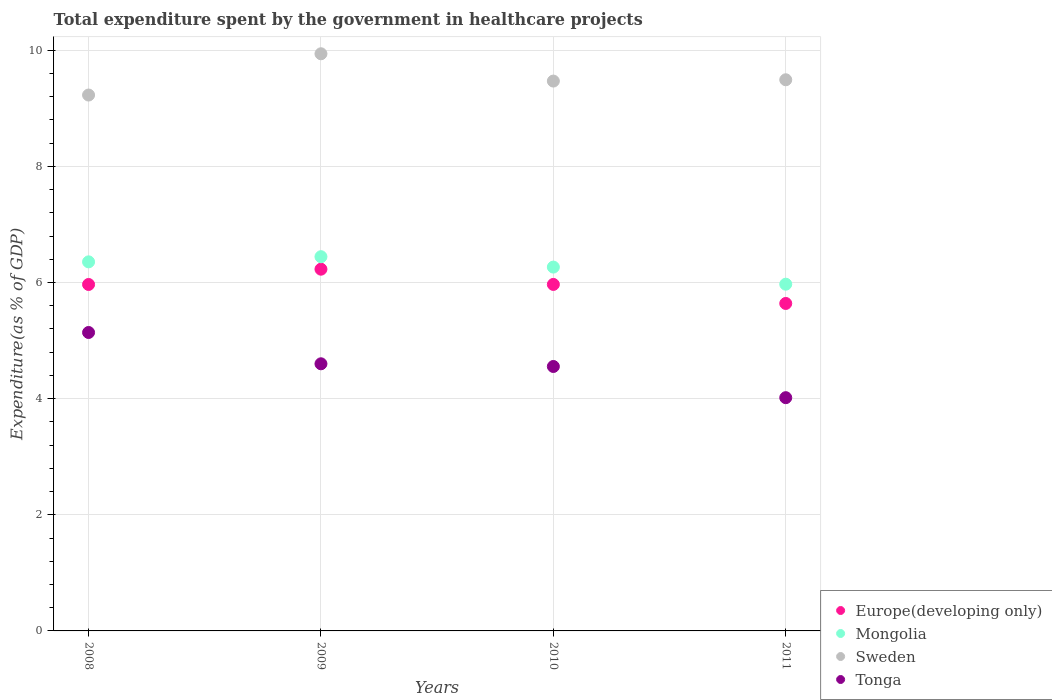How many different coloured dotlines are there?
Ensure brevity in your answer.  4. What is the total expenditure spent by the government in healthcare projects in Sweden in 2011?
Keep it short and to the point. 9.49. Across all years, what is the maximum total expenditure spent by the government in healthcare projects in Sweden?
Offer a very short reply. 9.94. Across all years, what is the minimum total expenditure spent by the government in healthcare projects in Europe(developing only)?
Give a very brief answer. 5.64. In which year was the total expenditure spent by the government in healthcare projects in Mongolia minimum?
Your answer should be compact. 2011. What is the total total expenditure spent by the government in healthcare projects in Mongolia in the graph?
Offer a terse response. 25.04. What is the difference between the total expenditure spent by the government in healthcare projects in Sweden in 2009 and that in 2010?
Give a very brief answer. 0.47. What is the difference between the total expenditure spent by the government in healthcare projects in Sweden in 2011 and the total expenditure spent by the government in healthcare projects in Tonga in 2009?
Your response must be concise. 4.89. What is the average total expenditure spent by the government in healthcare projects in Mongolia per year?
Ensure brevity in your answer.  6.26. In the year 2011, what is the difference between the total expenditure spent by the government in healthcare projects in Mongolia and total expenditure spent by the government in healthcare projects in Tonga?
Provide a succinct answer. 1.95. What is the ratio of the total expenditure spent by the government in healthcare projects in Europe(developing only) in 2008 to that in 2009?
Make the answer very short. 0.96. Is the total expenditure spent by the government in healthcare projects in Tonga in 2009 less than that in 2011?
Your answer should be compact. No. Is the difference between the total expenditure spent by the government in healthcare projects in Mongolia in 2009 and 2010 greater than the difference between the total expenditure spent by the government in healthcare projects in Tonga in 2009 and 2010?
Offer a very short reply. Yes. What is the difference between the highest and the second highest total expenditure spent by the government in healthcare projects in Europe(developing only)?
Give a very brief answer. 0.26. What is the difference between the highest and the lowest total expenditure spent by the government in healthcare projects in Europe(developing only)?
Your answer should be compact. 0.59. Is the total expenditure spent by the government in healthcare projects in Mongolia strictly greater than the total expenditure spent by the government in healthcare projects in Tonga over the years?
Offer a terse response. Yes. How many dotlines are there?
Your response must be concise. 4. Does the graph contain any zero values?
Offer a terse response. No. How many legend labels are there?
Offer a very short reply. 4. How are the legend labels stacked?
Provide a short and direct response. Vertical. What is the title of the graph?
Offer a terse response. Total expenditure spent by the government in healthcare projects. Does "Austria" appear as one of the legend labels in the graph?
Your answer should be very brief. No. What is the label or title of the X-axis?
Your answer should be very brief. Years. What is the label or title of the Y-axis?
Your answer should be compact. Expenditure(as % of GDP). What is the Expenditure(as % of GDP) of Europe(developing only) in 2008?
Offer a very short reply. 5.97. What is the Expenditure(as % of GDP) in Mongolia in 2008?
Give a very brief answer. 6.36. What is the Expenditure(as % of GDP) of Sweden in 2008?
Make the answer very short. 9.23. What is the Expenditure(as % of GDP) in Tonga in 2008?
Offer a very short reply. 5.14. What is the Expenditure(as % of GDP) of Europe(developing only) in 2009?
Make the answer very short. 6.23. What is the Expenditure(as % of GDP) in Mongolia in 2009?
Give a very brief answer. 6.44. What is the Expenditure(as % of GDP) in Sweden in 2009?
Offer a very short reply. 9.94. What is the Expenditure(as % of GDP) of Tonga in 2009?
Your answer should be very brief. 4.6. What is the Expenditure(as % of GDP) of Europe(developing only) in 2010?
Provide a short and direct response. 5.97. What is the Expenditure(as % of GDP) of Mongolia in 2010?
Ensure brevity in your answer.  6.27. What is the Expenditure(as % of GDP) of Sweden in 2010?
Your answer should be very brief. 9.47. What is the Expenditure(as % of GDP) of Tonga in 2010?
Keep it short and to the point. 4.55. What is the Expenditure(as % of GDP) in Europe(developing only) in 2011?
Keep it short and to the point. 5.64. What is the Expenditure(as % of GDP) of Mongolia in 2011?
Ensure brevity in your answer.  5.97. What is the Expenditure(as % of GDP) in Sweden in 2011?
Provide a short and direct response. 9.49. What is the Expenditure(as % of GDP) in Tonga in 2011?
Ensure brevity in your answer.  4.02. Across all years, what is the maximum Expenditure(as % of GDP) of Europe(developing only)?
Your answer should be very brief. 6.23. Across all years, what is the maximum Expenditure(as % of GDP) in Mongolia?
Provide a short and direct response. 6.44. Across all years, what is the maximum Expenditure(as % of GDP) of Sweden?
Your answer should be compact. 9.94. Across all years, what is the maximum Expenditure(as % of GDP) of Tonga?
Make the answer very short. 5.14. Across all years, what is the minimum Expenditure(as % of GDP) in Europe(developing only)?
Give a very brief answer. 5.64. Across all years, what is the minimum Expenditure(as % of GDP) of Mongolia?
Offer a terse response. 5.97. Across all years, what is the minimum Expenditure(as % of GDP) of Sweden?
Keep it short and to the point. 9.23. Across all years, what is the minimum Expenditure(as % of GDP) of Tonga?
Provide a short and direct response. 4.02. What is the total Expenditure(as % of GDP) of Europe(developing only) in the graph?
Your response must be concise. 23.8. What is the total Expenditure(as % of GDP) in Mongolia in the graph?
Offer a very short reply. 25.04. What is the total Expenditure(as % of GDP) in Sweden in the graph?
Your answer should be very brief. 38.13. What is the total Expenditure(as % of GDP) in Tonga in the graph?
Provide a short and direct response. 18.31. What is the difference between the Expenditure(as % of GDP) in Europe(developing only) in 2008 and that in 2009?
Offer a very short reply. -0.26. What is the difference between the Expenditure(as % of GDP) in Mongolia in 2008 and that in 2009?
Keep it short and to the point. -0.09. What is the difference between the Expenditure(as % of GDP) of Sweden in 2008 and that in 2009?
Your response must be concise. -0.71. What is the difference between the Expenditure(as % of GDP) of Tonga in 2008 and that in 2009?
Keep it short and to the point. 0.54. What is the difference between the Expenditure(as % of GDP) of Europe(developing only) in 2008 and that in 2010?
Your answer should be compact. -0. What is the difference between the Expenditure(as % of GDP) in Mongolia in 2008 and that in 2010?
Offer a very short reply. 0.09. What is the difference between the Expenditure(as % of GDP) in Sweden in 2008 and that in 2010?
Offer a very short reply. -0.24. What is the difference between the Expenditure(as % of GDP) of Tonga in 2008 and that in 2010?
Your response must be concise. 0.59. What is the difference between the Expenditure(as % of GDP) of Europe(developing only) in 2008 and that in 2011?
Make the answer very short. 0.33. What is the difference between the Expenditure(as % of GDP) in Mongolia in 2008 and that in 2011?
Offer a terse response. 0.38. What is the difference between the Expenditure(as % of GDP) of Sweden in 2008 and that in 2011?
Ensure brevity in your answer.  -0.26. What is the difference between the Expenditure(as % of GDP) of Tonga in 2008 and that in 2011?
Make the answer very short. 1.12. What is the difference between the Expenditure(as % of GDP) in Europe(developing only) in 2009 and that in 2010?
Ensure brevity in your answer.  0.26. What is the difference between the Expenditure(as % of GDP) of Mongolia in 2009 and that in 2010?
Your response must be concise. 0.18. What is the difference between the Expenditure(as % of GDP) in Sweden in 2009 and that in 2010?
Provide a succinct answer. 0.47. What is the difference between the Expenditure(as % of GDP) in Tonga in 2009 and that in 2010?
Your response must be concise. 0.05. What is the difference between the Expenditure(as % of GDP) in Europe(developing only) in 2009 and that in 2011?
Offer a very short reply. 0.59. What is the difference between the Expenditure(as % of GDP) in Mongolia in 2009 and that in 2011?
Make the answer very short. 0.47. What is the difference between the Expenditure(as % of GDP) in Sweden in 2009 and that in 2011?
Ensure brevity in your answer.  0.45. What is the difference between the Expenditure(as % of GDP) in Tonga in 2009 and that in 2011?
Give a very brief answer. 0.58. What is the difference between the Expenditure(as % of GDP) of Europe(developing only) in 2010 and that in 2011?
Make the answer very short. 0.33. What is the difference between the Expenditure(as % of GDP) in Mongolia in 2010 and that in 2011?
Keep it short and to the point. 0.29. What is the difference between the Expenditure(as % of GDP) in Sweden in 2010 and that in 2011?
Your answer should be compact. -0.02. What is the difference between the Expenditure(as % of GDP) of Tonga in 2010 and that in 2011?
Ensure brevity in your answer.  0.54. What is the difference between the Expenditure(as % of GDP) in Europe(developing only) in 2008 and the Expenditure(as % of GDP) in Mongolia in 2009?
Your response must be concise. -0.48. What is the difference between the Expenditure(as % of GDP) of Europe(developing only) in 2008 and the Expenditure(as % of GDP) of Sweden in 2009?
Provide a short and direct response. -3.97. What is the difference between the Expenditure(as % of GDP) in Europe(developing only) in 2008 and the Expenditure(as % of GDP) in Tonga in 2009?
Offer a terse response. 1.37. What is the difference between the Expenditure(as % of GDP) of Mongolia in 2008 and the Expenditure(as % of GDP) of Sweden in 2009?
Offer a terse response. -3.58. What is the difference between the Expenditure(as % of GDP) of Mongolia in 2008 and the Expenditure(as % of GDP) of Tonga in 2009?
Your response must be concise. 1.76. What is the difference between the Expenditure(as % of GDP) of Sweden in 2008 and the Expenditure(as % of GDP) of Tonga in 2009?
Your answer should be compact. 4.63. What is the difference between the Expenditure(as % of GDP) of Europe(developing only) in 2008 and the Expenditure(as % of GDP) of Mongolia in 2010?
Make the answer very short. -0.3. What is the difference between the Expenditure(as % of GDP) of Europe(developing only) in 2008 and the Expenditure(as % of GDP) of Sweden in 2010?
Provide a succinct answer. -3.5. What is the difference between the Expenditure(as % of GDP) of Europe(developing only) in 2008 and the Expenditure(as % of GDP) of Tonga in 2010?
Offer a very short reply. 1.41. What is the difference between the Expenditure(as % of GDP) of Mongolia in 2008 and the Expenditure(as % of GDP) of Sweden in 2010?
Offer a very short reply. -3.11. What is the difference between the Expenditure(as % of GDP) of Mongolia in 2008 and the Expenditure(as % of GDP) of Tonga in 2010?
Make the answer very short. 1.8. What is the difference between the Expenditure(as % of GDP) in Sweden in 2008 and the Expenditure(as % of GDP) in Tonga in 2010?
Offer a terse response. 4.67. What is the difference between the Expenditure(as % of GDP) of Europe(developing only) in 2008 and the Expenditure(as % of GDP) of Mongolia in 2011?
Your answer should be very brief. -0. What is the difference between the Expenditure(as % of GDP) in Europe(developing only) in 2008 and the Expenditure(as % of GDP) in Sweden in 2011?
Make the answer very short. -3.53. What is the difference between the Expenditure(as % of GDP) in Europe(developing only) in 2008 and the Expenditure(as % of GDP) in Tonga in 2011?
Provide a short and direct response. 1.95. What is the difference between the Expenditure(as % of GDP) in Mongolia in 2008 and the Expenditure(as % of GDP) in Sweden in 2011?
Make the answer very short. -3.14. What is the difference between the Expenditure(as % of GDP) in Mongolia in 2008 and the Expenditure(as % of GDP) in Tonga in 2011?
Provide a short and direct response. 2.34. What is the difference between the Expenditure(as % of GDP) of Sweden in 2008 and the Expenditure(as % of GDP) of Tonga in 2011?
Your answer should be compact. 5.21. What is the difference between the Expenditure(as % of GDP) in Europe(developing only) in 2009 and the Expenditure(as % of GDP) in Mongolia in 2010?
Your answer should be compact. -0.04. What is the difference between the Expenditure(as % of GDP) in Europe(developing only) in 2009 and the Expenditure(as % of GDP) in Sweden in 2010?
Give a very brief answer. -3.24. What is the difference between the Expenditure(as % of GDP) in Europe(developing only) in 2009 and the Expenditure(as % of GDP) in Tonga in 2010?
Your response must be concise. 1.68. What is the difference between the Expenditure(as % of GDP) of Mongolia in 2009 and the Expenditure(as % of GDP) of Sweden in 2010?
Your answer should be very brief. -3.02. What is the difference between the Expenditure(as % of GDP) in Mongolia in 2009 and the Expenditure(as % of GDP) in Tonga in 2010?
Offer a very short reply. 1.89. What is the difference between the Expenditure(as % of GDP) in Sweden in 2009 and the Expenditure(as % of GDP) in Tonga in 2010?
Your answer should be very brief. 5.39. What is the difference between the Expenditure(as % of GDP) of Europe(developing only) in 2009 and the Expenditure(as % of GDP) of Mongolia in 2011?
Offer a terse response. 0.26. What is the difference between the Expenditure(as % of GDP) of Europe(developing only) in 2009 and the Expenditure(as % of GDP) of Sweden in 2011?
Offer a terse response. -3.26. What is the difference between the Expenditure(as % of GDP) in Europe(developing only) in 2009 and the Expenditure(as % of GDP) in Tonga in 2011?
Offer a terse response. 2.21. What is the difference between the Expenditure(as % of GDP) in Mongolia in 2009 and the Expenditure(as % of GDP) in Sweden in 2011?
Your answer should be very brief. -3.05. What is the difference between the Expenditure(as % of GDP) in Mongolia in 2009 and the Expenditure(as % of GDP) in Tonga in 2011?
Your response must be concise. 2.43. What is the difference between the Expenditure(as % of GDP) of Sweden in 2009 and the Expenditure(as % of GDP) of Tonga in 2011?
Ensure brevity in your answer.  5.92. What is the difference between the Expenditure(as % of GDP) of Europe(developing only) in 2010 and the Expenditure(as % of GDP) of Mongolia in 2011?
Give a very brief answer. -0. What is the difference between the Expenditure(as % of GDP) in Europe(developing only) in 2010 and the Expenditure(as % of GDP) in Sweden in 2011?
Give a very brief answer. -3.52. What is the difference between the Expenditure(as % of GDP) of Europe(developing only) in 2010 and the Expenditure(as % of GDP) of Tonga in 2011?
Ensure brevity in your answer.  1.95. What is the difference between the Expenditure(as % of GDP) in Mongolia in 2010 and the Expenditure(as % of GDP) in Sweden in 2011?
Provide a succinct answer. -3.23. What is the difference between the Expenditure(as % of GDP) in Mongolia in 2010 and the Expenditure(as % of GDP) in Tonga in 2011?
Your answer should be very brief. 2.25. What is the difference between the Expenditure(as % of GDP) of Sweden in 2010 and the Expenditure(as % of GDP) of Tonga in 2011?
Your answer should be compact. 5.45. What is the average Expenditure(as % of GDP) in Europe(developing only) per year?
Keep it short and to the point. 5.95. What is the average Expenditure(as % of GDP) of Mongolia per year?
Keep it short and to the point. 6.26. What is the average Expenditure(as % of GDP) in Sweden per year?
Your answer should be compact. 9.53. What is the average Expenditure(as % of GDP) of Tonga per year?
Make the answer very short. 4.58. In the year 2008, what is the difference between the Expenditure(as % of GDP) of Europe(developing only) and Expenditure(as % of GDP) of Mongolia?
Your answer should be very brief. -0.39. In the year 2008, what is the difference between the Expenditure(as % of GDP) of Europe(developing only) and Expenditure(as % of GDP) of Sweden?
Your answer should be very brief. -3.26. In the year 2008, what is the difference between the Expenditure(as % of GDP) in Europe(developing only) and Expenditure(as % of GDP) in Tonga?
Provide a succinct answer. 0.83. In the year 2008, what is the difference between the Expenditure(as % of GDP) of Mongolia and Expenditure(as % of GDP) of Sweden?
Your response must be concise. -2.87. In the year 2008, what is the difference between the Expenditure(as % of GDP) of Mongolia and Expenditure(as % of GDP) of Tonga?
Give a very brief answer. 1.22. In the year 2008, what is the difference between the Expenditure(as % of GDP) of Sweden and Expenditure(as % of GDP) of Tonga?
Ensure brevity in your answer.  4.09. In the year 2009, what is the difference between the Expenditure(as % of GDP) of Europe(developing only) and Expenditure(as % of GDP) of Mongolia?
Provide a short and direct response. -0.22. In the year 2009, what is the difference between the Expenditure(as % of GDP) in Europe(developing only) and Expenditure(as % of GDP) in Sweden?
Provide a succinct answer. -3.71. In the year 2009, what is the difference between the Expenditure(as % of GDP) in Europe(developing only) and Expenditure(as % of GDP) in Tonga?
Ensure brevity in your answer.  1.63. In the year 2009, what is the difference between the Expenditure(as % of GDP) in Mongolia and Expenditure(as % of GDP) in Sweden?
Keep it short and to the point. -3.49. In the year 2009, what is the difference between the Expenditure(as % of GDP) of Mongolia and Expenditure(as % of GDP) of Tonga?
Provide a short and direct response. 1.84. In the year 2009, what is the difference between the Expenditure(as % of GDP) in Sweden and Expenditure(as % of GDP) in Tonga?
Provide a succinct answer. 5.34. In the year 2010, what is the difference between the Expenditure(as % of GDP) in Europe(developing only) and Expenditure(as % of GDP) in Mongolia?
Your answer should be very brief. -0.3. In the year 2010, what is the difference between the Expenditure(as % of GDP) in Europe(developing only) and Expenditure(as % of GDP) in Sweden?
Provide a short and direct response. -3.5. In the year 2010, what is the difference between the Expenditure(as % of GDP) in Europe(developing only) and Expenditure(as % of GDP) in Tonga?
Provide a succinct answer. 1.41. In the year 2010, what is the difference between the Expenditure(as % of GDP) in Mongolia and Expenditure(as % of GDP) in Sweden?
Your answer should be very brief. -3.2. In the year 2010, what is the difference between the Expenditure(as % of GDP) in Mongolia and Expenditure(as % of GDP) in Tonga?
Your answer should be compact. 1.71. In the year 2010, what is the difference between the Expenditure(as % of GDP) in Sweden and Expenditure(as % of GDP) in Tonga?
Make the answer very short. 4.92. In the year 2011, what is the difference between the Expenditure(as % of GDP) of Europe(developing only) and Expenditure(as % of GDP) of Mongolia?
Your answer should be compact. -0.33. In the year 2011, what is the difference between the Expenditure(as % of GDP) of Europe(developing only) and Expenditure(as % of GDP) of Sweden?
Ensure brevity in your answer.  -3.85. In the year 2011, what is the difference between the Expenditure(as % of GDP) in Europe(developing only) and Expenditure(as % of GDP) in Tonga?
Offer a very short reply. 1.62. In the year 2011, what is the difference between the Expenditure(as % of GDP) of Mongolia and Expenditure(as % of GDP) of Sweden?
Ensure brevity in your answer.  -3.52. In the year 2011, what is the difference between the Expenditure(as % of GDP) of Mongolia and Expenditure(as % of GDP) of Tonga?
Ensure brevity in your answer.  1.95. In the year 2011, what is the difference between the Expenditure(as % of GDP) in Sweden and Expenditure(as % of GDP) in Tonga?
Your response must be concise. 5.47. What is the ratio of the Expenditure(as % of GDP) of Europe(developing only) in 2008 to that in 2009?
Your answer should be compact. 0.96. What is the ratio of the Expenditure(as % of GDP) of Mongolia in 2008 to that in 2009?
Your answer should be very brief. 0.99. What is the ratio of the Expenditure(as % of GDP) of Sweden in 2008 to that in 2009?
Your answer should be very brief. 0.93. What is the ratio of the Expenditure(as % of GDP) in Tonga in 2008 to that in 2009?
Make the answer very short. 1.12. What is the ratio of the Expenditure(as % of GDP) of Europe(developing only) in 2008 to that in 2010?
Offer a terse response. 1. What is the ratio of the Expenditure(as % of GDP) in Mongolia in 2008 to that in 2010?
Your response must be concise. 1.01. What is the ratio of the Expenditure(as % of GDP) of Sweden in 2008 to that in 2010?
Provide a succinct answer. 0.97. What is the ratio of the Expenditure(as % of GDP) in Tonga in 2008 to that in 2010?
Give a very brief answer. 1.13. What is the ratio of the Expenditure(as % of GDP) of Europe(developing only) in 2008 to that in 2011?
Your response must be concise. 1.06. What is the ratio of the Expenditure(as % of GDP) in Mongolia in 2008 to that in 2011?
Ensure brevity in your answer.  1.06. What is the ratio of the Expenditure(as % of GDP) in Sweden in 2008 to that in 2011?
Provide a succinct answer. 0.97. What is the ratio of the Expenditure(as % of GDP) of Tonga in 2008 to that in 2011?
Provide a short and direct response. 1.28. What is the ratio of the Expenditure(as % of GDP) in Europe(developing only) in 2009 to that in 2010?
Provide a succinct answer. 1.04. What is the ratio of the Expenditure(as % of GDP) of Mongolia in 2009 to that in 2010?
Ensure brevity in your answer.  1.03. What is the ratio of the Expenditure(as % of GDP) in Sweden in 2009 to that in 2010?
Offer a very short reply. 1.05. What is the ratio of the Expenditure(as % of GDP) in Tonga in 2009 to that in 2010?
Provide a short and direct response. 1.01. What is the ratio of the Expenditure(as % of GDP) of Europe(developing only) in 2009 to that in 2011?
Offer a very short reply. 1.1. What is the ratio of the Expenditure(as % of GDP) in Mongolia in 2009 to that in 2011?
Provide a short and direct response. 1.08. What is the ratio of the Expenditure(as % of GDP) of Sweden in 2009 to that in 2011?
Ensure brevity in your answer.  1.05. What is the ratio of the Expenditure(as % of GDP) in Tonga in 2009 to that in 2011?
Your answer should be very brief. 1.15. What is the ratio of the Expenditure(as % of GDP) in Europe(developing only) in 2010 to that in 2011?
Ensure brevity in your answer.  1.06. What is the ratio of the Expenditure(as % of GDP) of Mongolia in 2010 to that in 2011?
Make the answer very short. 1.05. What is the ratio of the Expenditure(as % of GDP) in Sweden in 2010 to that in 2011?
Ensure brevity in your answer.  1. What is the ratio of the Expenditure(as % of GDP) in Tonga in 2010 to that in 2011?
Provide a succinct answer. 1.13. What is the difference between the highest and the second highest Expenditure(as % of GDP) in Europe(developing only)?
Your answer should be very brief. 0.26. What is the difference between the highest and the second highest Expenditure(as % of GDP) in Mongolia?
Make the answer very short. 0.09. What is the difference between the highest and the second highest Expenditure(as % of GDP) in Sweden?
Give a very brief answer. 0.45. What is the difference between the highest and the second highest Expenditure(as % of GDP) of Tonga?
Ensure brevity in your answer.  0.54. What is the difference between the highest and the lowest Expenditure(as % of GDP) of Europe(developing only)?
Your response must be concise. 0.59. What is the difference between the highest and the lowest Expenditure(as % of GDP) of Mongolia?
Provide a short and direct response. 0.47. What is the difference between the highest and the lowest Expenditure(as % of GDP) of Sweden?
Offer a very short reply. 0.71. What is the difference between the highest and the lowest Expenditure(as % of GDP) in Tonga?
Provide a succinct answer. 1.12. 